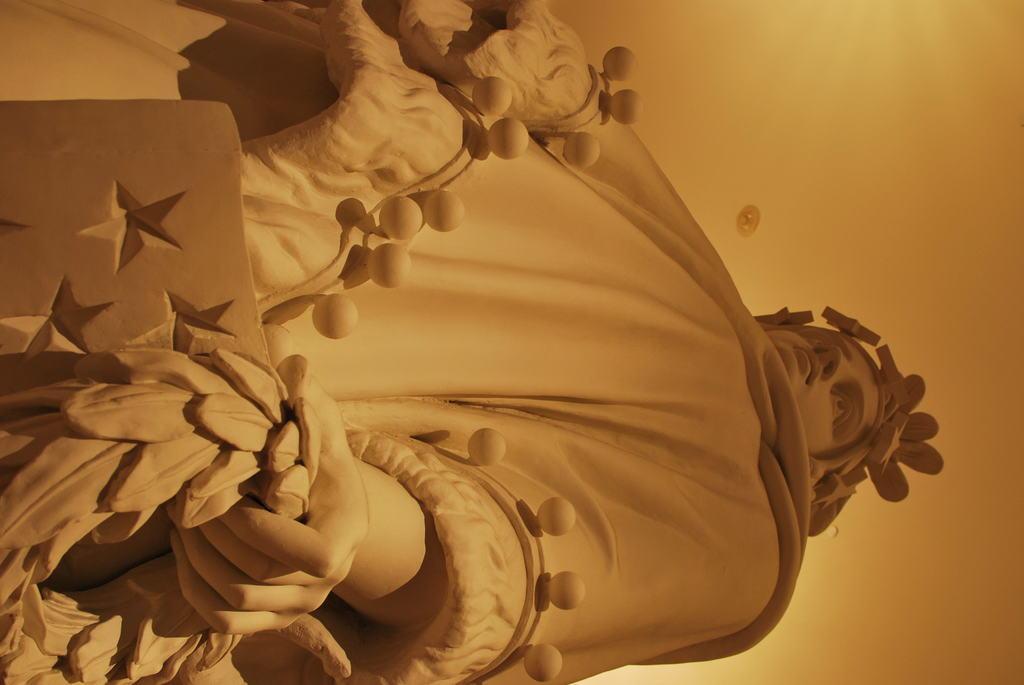Please provide a concise description of this image. In this image, we can see a human statue holding some objects. 